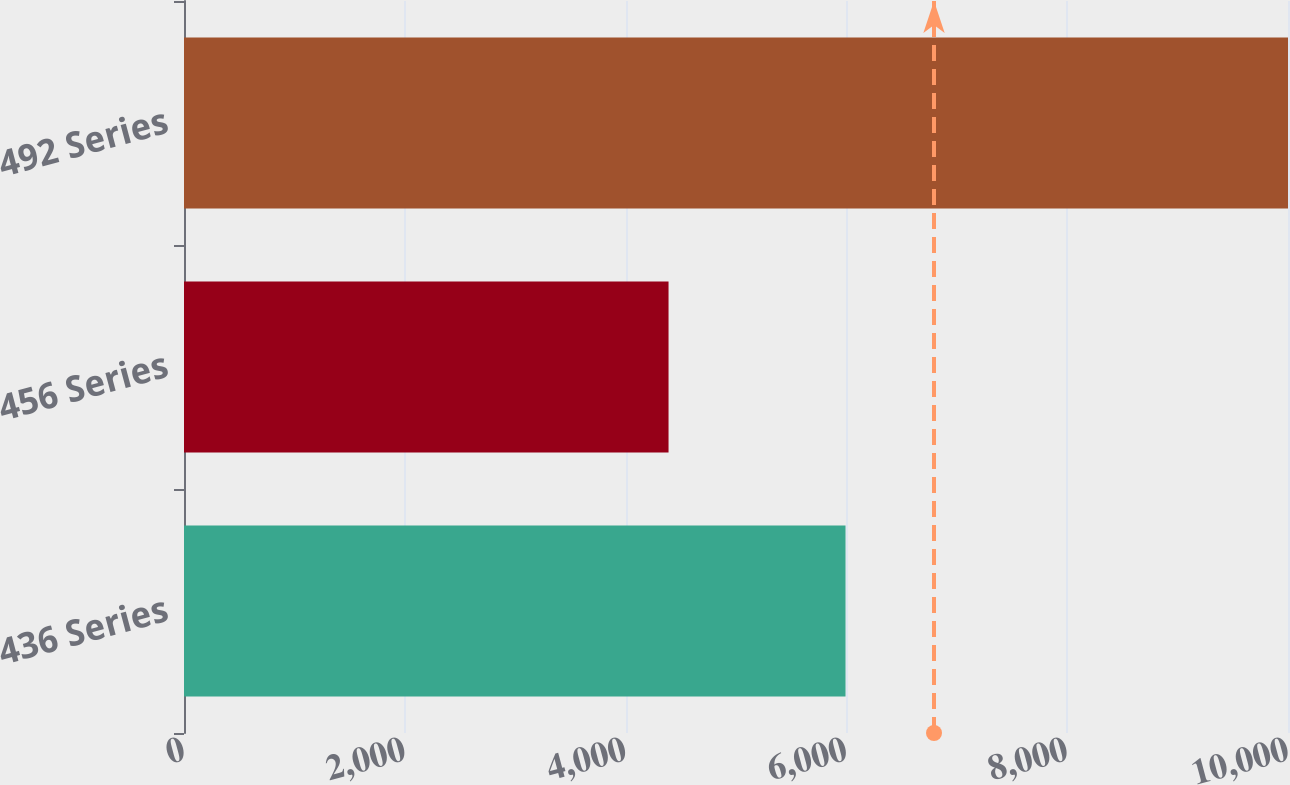Convert chart. <chart><loc_0><loc_0><loc_500><loc_500><bar_chart><fcel>436 Series<fcel>456 Series<fcel>492 Series<nl><fcel>5992<fcel>4389<fcel>10000<nl></chart> 